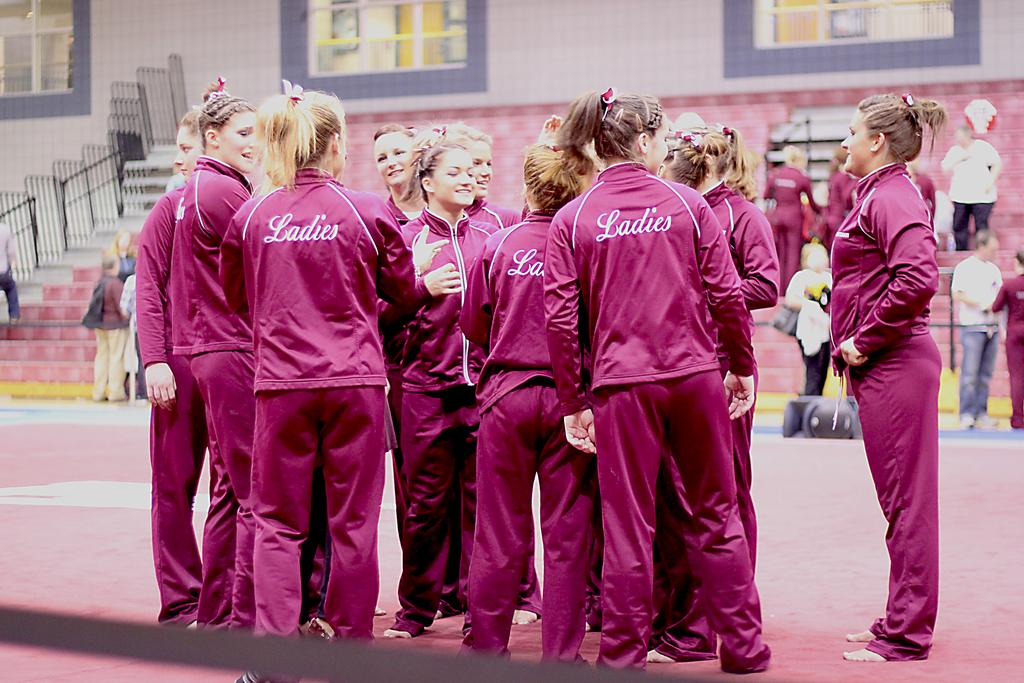What can be seen in the foreground of the image? There are ladies standing in the image. What is located behind the ladies? There are steps with people behind the ladies. What can be seen in the background of the image? There is a railing and a wall with glass windows in the background of the image. What type of scissors are being used to cut the beef in the image? There is no beef or scissors present in the image. 